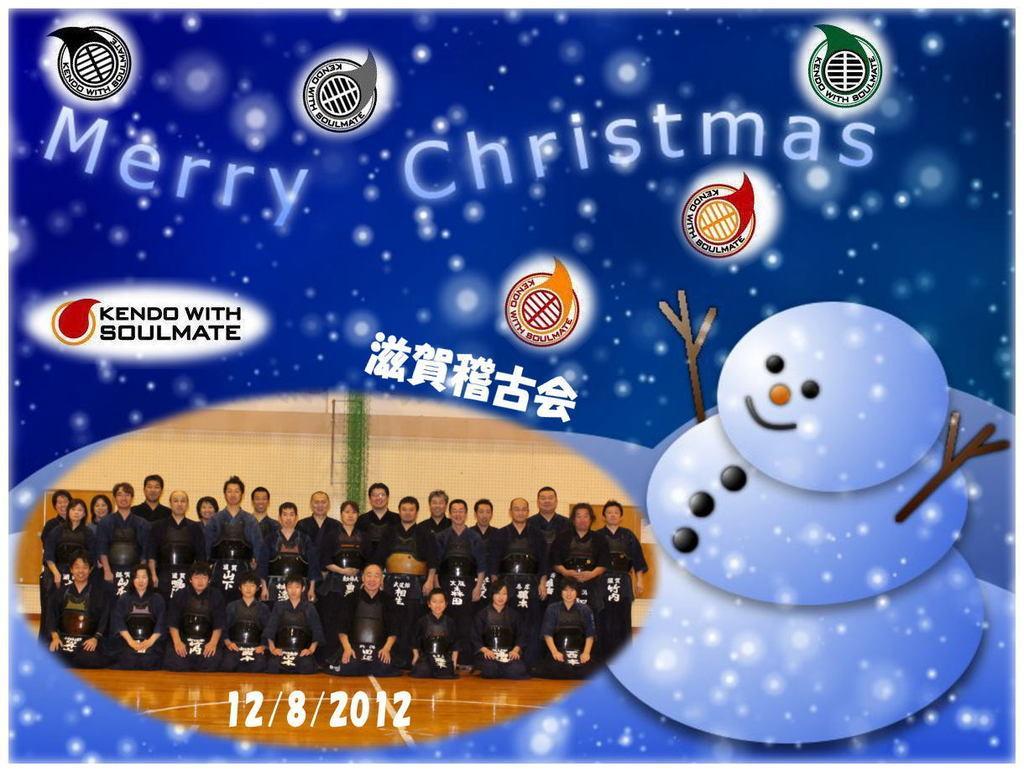Describe this image in one or two sentences. The picture is looking like a poster. On the left there is a group photograph and date. On the right we can see an animated snowman. At the top there is text and some logos. At the top we can see white color objects. 